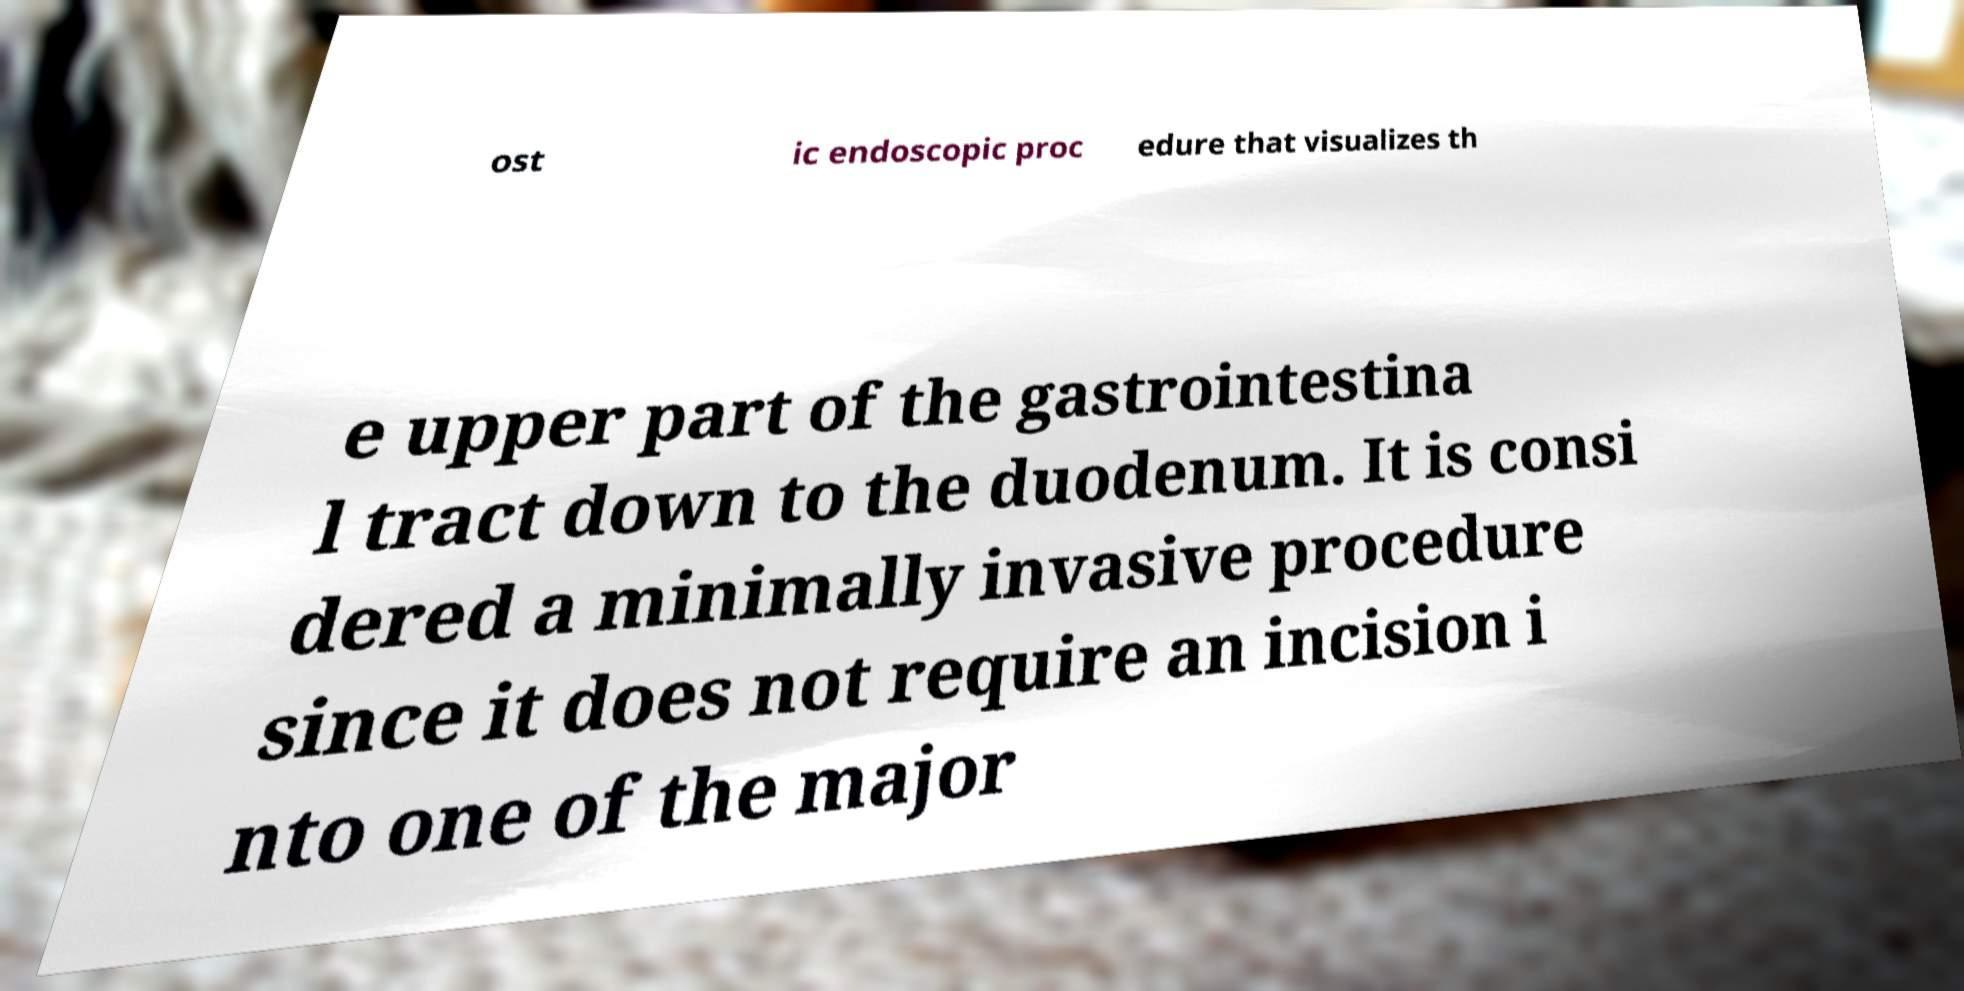Please identify and transcribe the text found in this image. ost ic endoscopic proc edure that visualizes th e upper part of the gastrointestina l tract down to the duodenum. It is consi dered a minimally invasive procedure since it does not require an incision i nto one of the major 